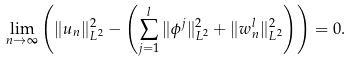Convert formula to latex. <formula><loc_0><loc_0><loc_500><loc_500>\lim _ { n \to \infty } \left ( \| u _ { n } \| ^ { 2 } _ { L ^ { 2 } } - \left ( \sum _ { j = 1 } ^ { l } \| \phi ^ { j } \| ^ { 2 } _ { L ^ { 2 } } + \| w _ { n } ^ { l } \| ^ { 2 } _ { L ^ { 2 } } \right ) \right ) = 0 .</formula> 